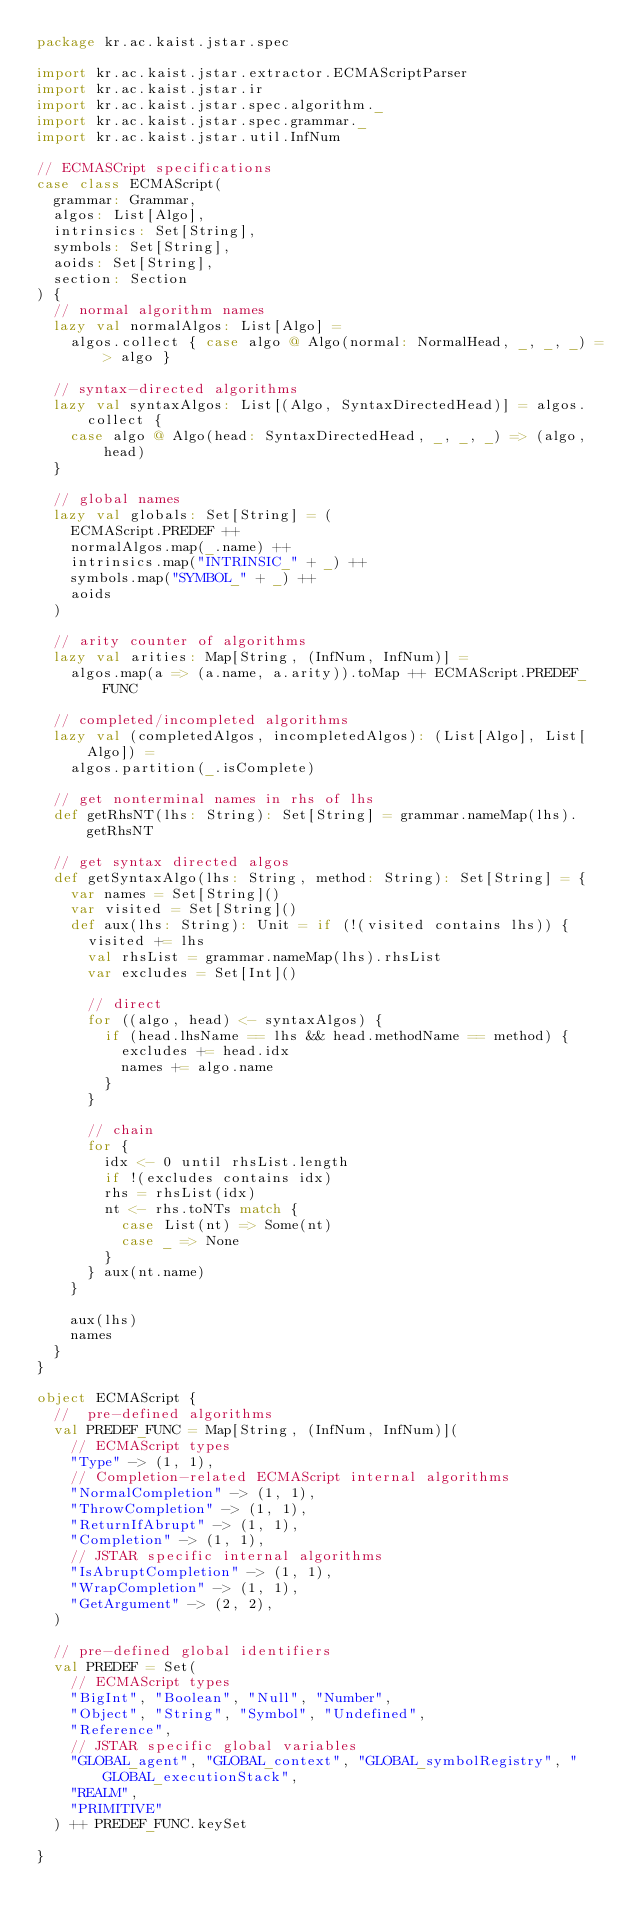Convert code to text. <code><loc_0><loc_0><loc_500><loc_500><_Scala_>package kr.ac.kaist.jstar.spec

import kr.ac.kaist.jstar.extractor.ECMAScriptParser
import kr.ac.kaist.jstar.ir
import kr.ac.kaist.jstar.spec.algorithm._
import kr.ac.kaist.jstar.spec.grammar._
import kr.ac.kaist.jstar.util.InfNum

// ECMASCript specifications
case class ECMAScript(
  grammar: Grammar,
  algos: List[Algo],
  intrinsics: Set[String],
  symbols: Set[String],
  aoids: Set[String],
  section: Section
) {
  // normal algorithm names
  lazy val normalAlgos: List[Algo] =
    algos.collect { case algo @ Algo(normal: NormalHead, _, _, _) => algo }

  // syntax-directed algorithms
  lazy val syntaxAlgos: List[(Algo, SyntaxDirectedHead)] = algos.collect {
    case algo @ Algo(head: SyntaxDirectedHead, _, _, _) => (algo, head)
  }

  // global names
  lazy val globals: Set[String] = (
    ECMAScript.PREDEF ++
    normalAlgos.map(_.name) ++
    intrinsics.map("INTRINSIC_" + _) ++
    symbols.map("SYMBOL_" + _) ++
    aoids
  )

  // arity counter of algorithms
  lazy val arities: Map[String, (InfNum, InfNum)] =
    algos.map(a => (a.name, a.arity)).toMap ++ ECMAScript.PREDEF_FUNC

  // completed/incompleted algorithms
  lazy val (completedAlgos, incompletedAlgos): (List[Algo], List[Algo]) =
    algos.partition(_.isComplete)

  // get nonterminal names in rhs of lhs
  def getRhsNT(lhs: String): Set[String] = grammar.nameMap(lhs).getRhsNT

  // get syntax directed algos
  def getSyntaxAlgo(lhs: String, method: String): Set[String] = {
    var names = Set[String]()
    var visited = Set[String]()
    def aux(lhs: String): Unit = if (!(visited contains lhs)) {
      visited += lhs
      val rhsList = grammar.nameMap(lhs).rhsList
      var excludes = Set[Int]()

      // direct
      for ((algo, head) <- syntaxAlgos) {
        if (head.lhsName == lhs && head.methodName == method) {
          excludes += head.idx
          names += algo.name
        }
      }

      // chain
      for {
        idx <- 0 until rhsList.length
        if !(excludes contains idx)
        rhs = rhsList(idx)
        nt <- rhs.toNTs match {
          case List(nt) => Some(nt)
          case _ => None
        }
      } aux(nt.name)
    }

    aux(lhs)
    names
  }
}

object ECMAScript {
  //  pre-defined algorithms
  val PREDEF_FUNC = Map[String, (InfNum, InfNum)](
    // ECMAScript types
    "Type" -> (1, 1),
    // Completion-related ECMAScript internal algorithms
    "NormalCompletion" -> (1, 1),
    "ThrowCompletion" -> (1, 1),
    "ReturnIfAbrupt" -> (1, 1),
    "Completion" -> (1, 1),
    // JSTAR specific internal algorithms
    "IsAbruptCompletion" -> (1, 1),
    "WrapCompletion" -> (1, 1),
    "GetArgument" -> (2, 2),
  )

  // pre-defined global identifiers
  val PREDEF = Set(
    // ECMAScript types
    "BigInt", "Boolean", "Null", "Number",
    "Object", "String", "Symbol", "Undefined",
    "Reference",
    // JSTAR specific global variables
    "GLOBAL_agent", "GLOBAL_context", "GLOBAL_symbolRegistry", "GLOBAL_executionStack",
    "REALM",
    "PRIMITIVE"
  ) ++ PREDEF_FUNC.keySet

}
</code> 